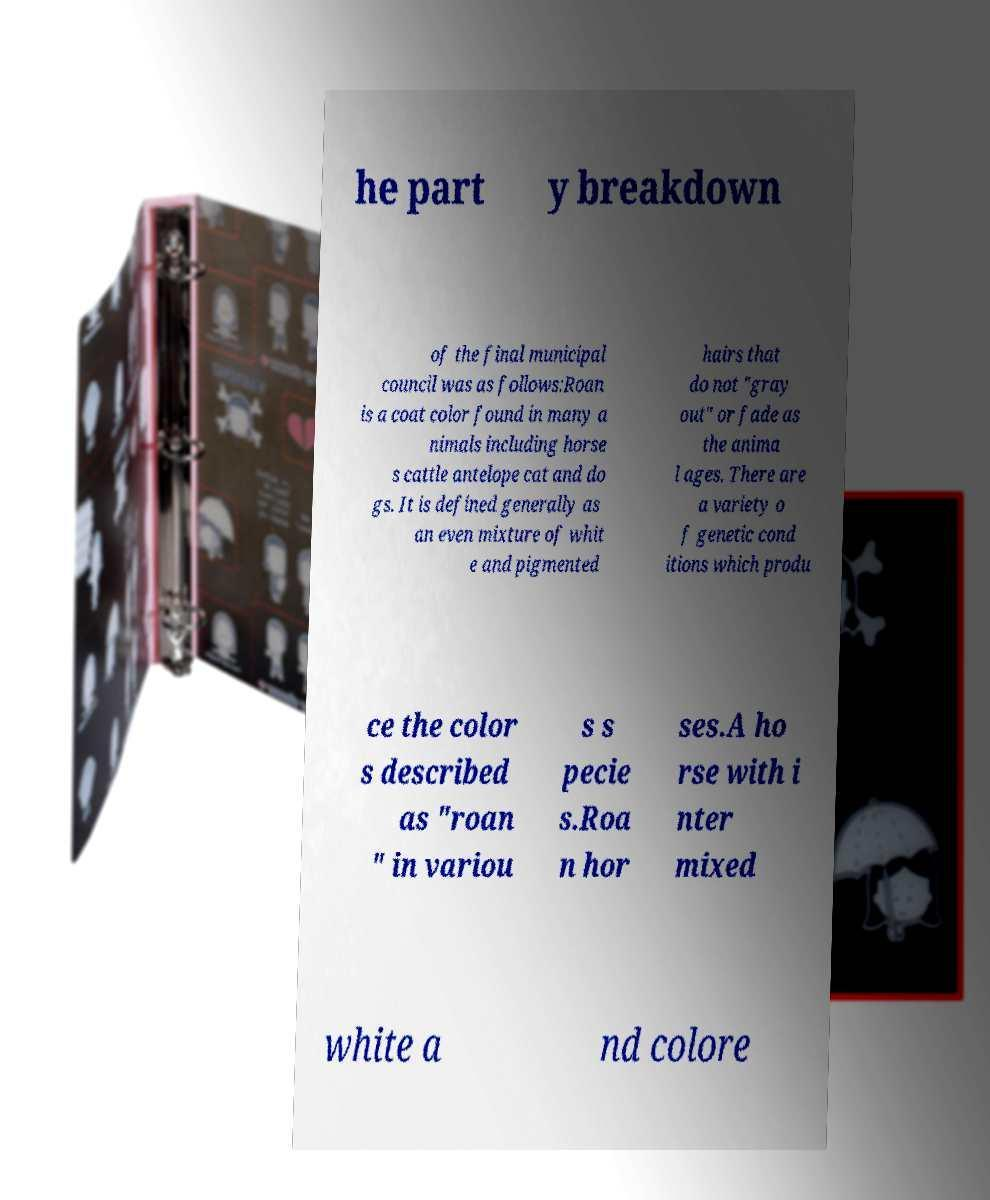There's text embedded in this image that I need extracted. Can you transcribe it verbatim? he part y breakdown of the final municipal council was as follows:Roan is a coat color found in many a nimals including horse s cattle antelope cat and do gs. It is defined generally as an even mixture of whit e and pigmented hairs that do not "gray out" or fade as the anima l ages. There are a variety o f genetic cond itions which produ ce the color s described as "roan " in variou s s pecie s.Roa n hor ses.A ho rse with i nter mixed white a nd colore 